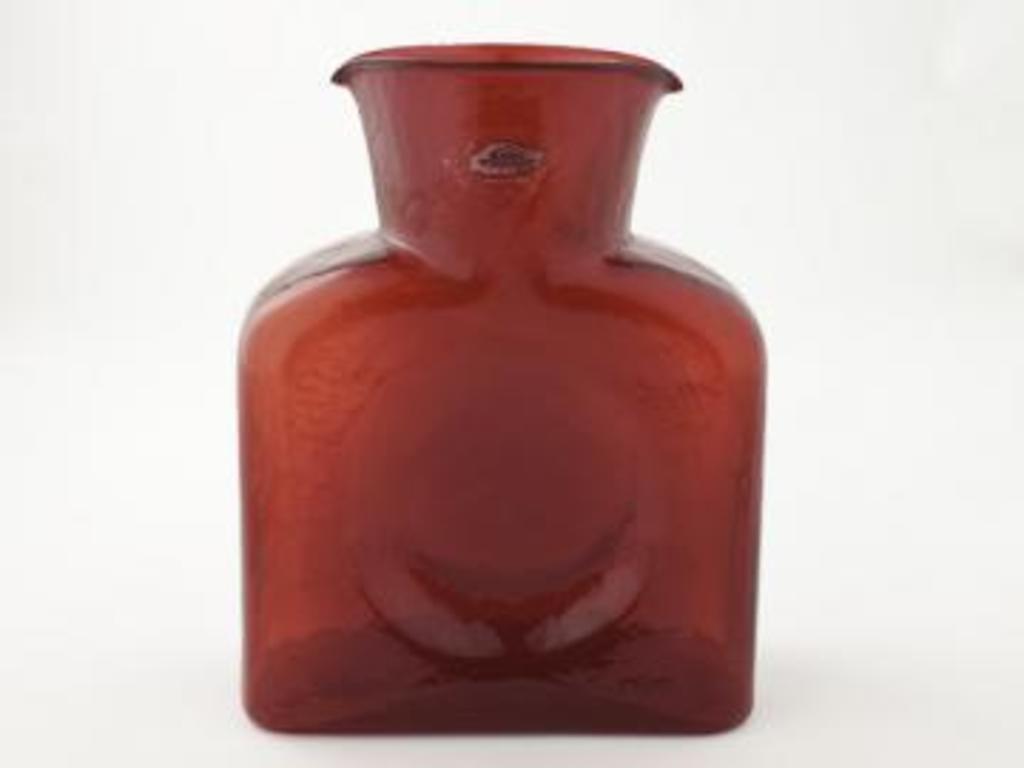Describe this image in one or two sentences. In this image there is a red color mug. There is a white color background. 